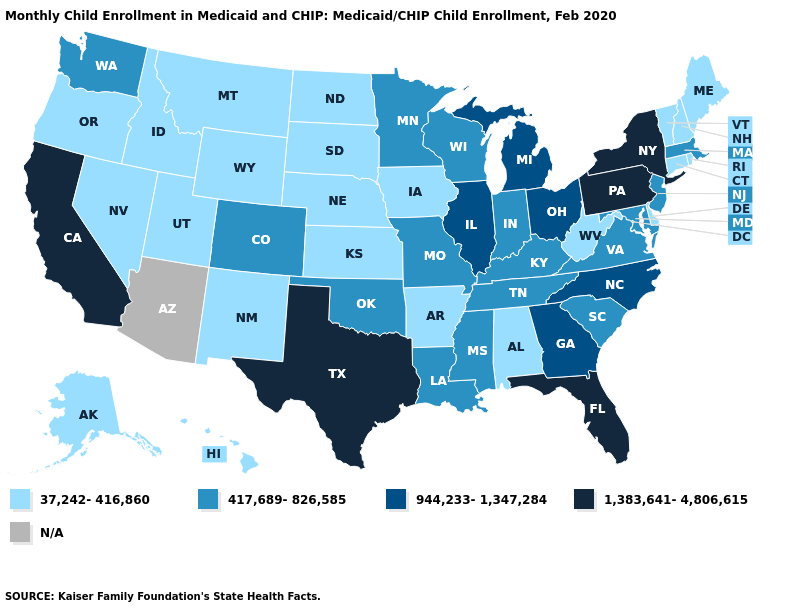Name the states that have a value in the range 417,689-826,585?
Be succinct. Colorado, Indiana, Kentucky, Louisiana, Maryland, Massachusetts, Minnesota, Mississippi, Missouri, New Jersey, Oklahoma, South Carolina, Tennessee, Virginia, Washington, Wisconsin. What is the value of Massachusetts?
Keep it brief. 417,689-826,585. Name the states that have a value in the range 37,242-416,860?
Write a very short answer. Alabama, Alaska, Arkansas, Connecticut, Delaware, Hawaii, Idaho, Iowa, Kansas, Maine, Montana, Nebraska, Nevada, New Hampshire, New Mexico, North Dakota, Oregon, Rhode Island, South Dakota, Utah, Vermont, West Virginia, Wyoming. Name the states that have a value in the range 37,242-416,860?
Short answer required. Alabama, Alaska, Arkansas, Connecticut, Delaware, Hawaii, Idaho, Iowa, Kansas, Maine, Montana, Nebraska, Nevada, New Hampshire, New Mexico, North Dakota, Oregon, Rhode Island, South Dakota, Utah, Vermont, West Virginia, Wyoming. Name the states that have a value in the range N/A?
Concise answer only. Arizona. Which states hav the highest value in the Northeast?
Give a very brief answer. New York, Pennsylvania. Does Tennessee have the lowest value in the USA?
Be succinct. No. What is the value of Minnesota?
Quick response, please. 417,689-826,585. Which states hav the highest value in the West?
Give a very brief answer. California. Name the states that have a value in the range 417,689-826,585?
Give a very brief answer. Colorado, Indiana, Kentucky, Louisiana, Maryland, Massachusetts, Minnesota, Mississippi, Missouri, New Jersey, Oklahoma, South Carolina, Tennessee, Virginia, Washington, Wisconsin. Among the states that border Oregon , does Nevada have the lowest value?
Keep it brief. Yes. 